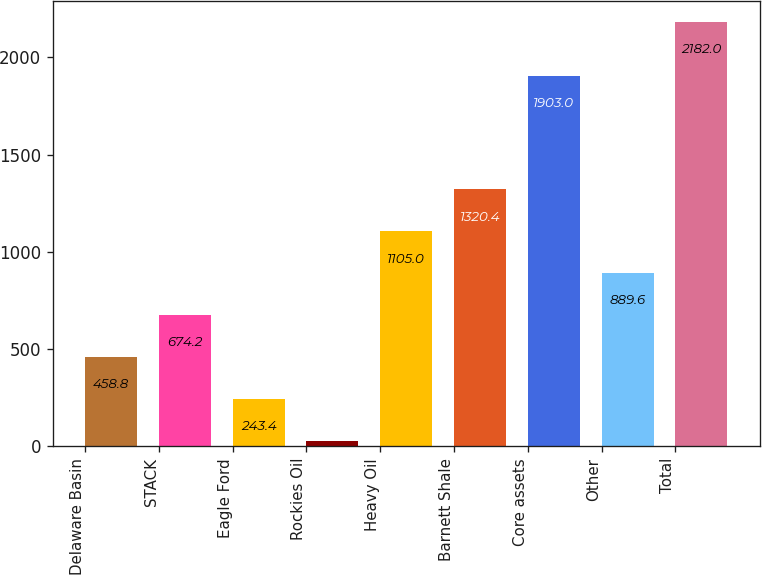<chart> <loc_0><loc_0><loc_500><loc_500><bar_chart><fcel>Delaware Basin<fcel>STACK<fcel>Eagle Ford<fcel>Rockies Oil<fcel>Heavy Oil<fcel>Barnett Shale<fcel>Core assets<fcel>Other<fcel>Total<nl><fcel>458.8<fcel>674.2<fcel>243.4<fcel>28<fcel>1105<fcel>1320.4<fcel>1903<fcel>889.6<fcel>2182<nl></chart> 